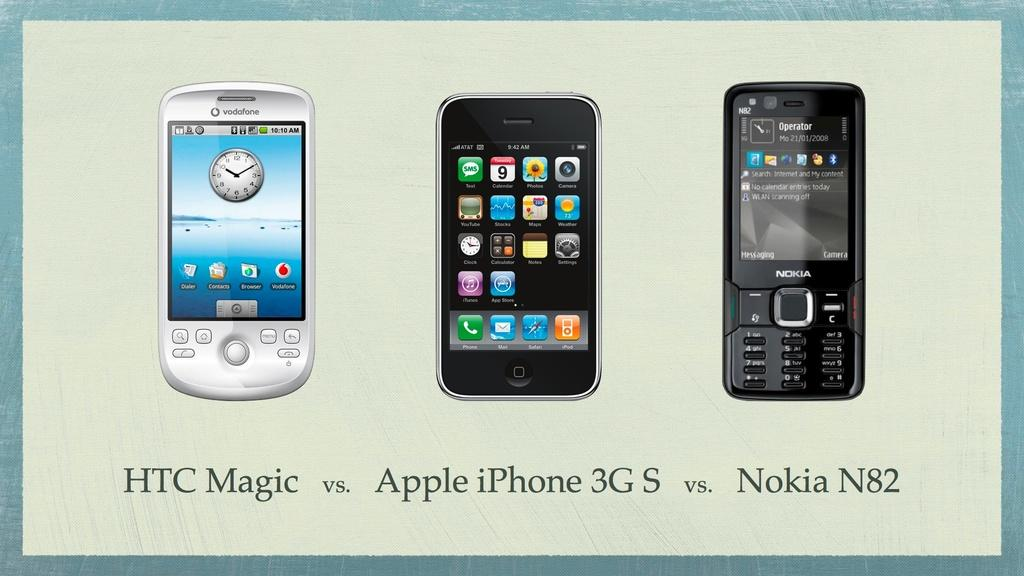Provide a one-sentence caption for the provided image. An ad compares an HTC, an Iphone, and a Nokia. 